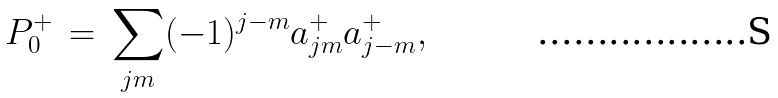<formula> <loc_0><loc_0><loc_500><loc_500>P _ { 0 } ^ { + } \, = \, \sum _ { j m } ( - 1 ) ^ { j - m } a _ { j m } ^ { + } a _ { j - m } ^ { + } ,</formula> 